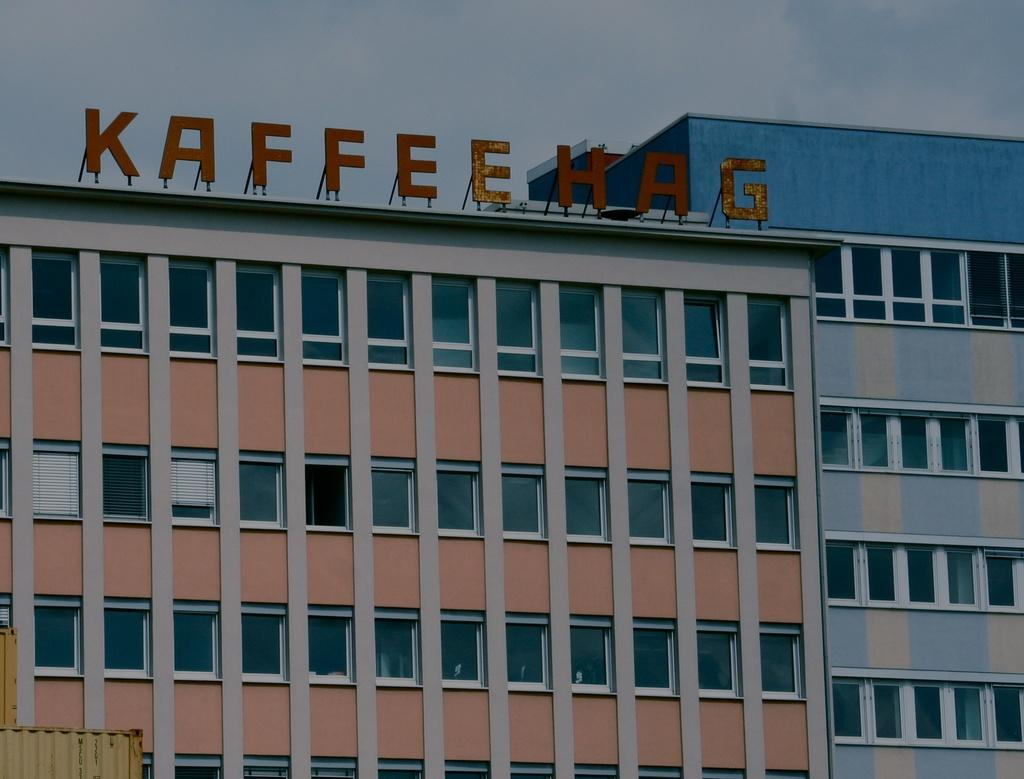What type of structure is in the image? There is a building in the image. What can be seen at the top of the image? Text is visible at the top of the image. What is present in the sky in the image? Clouds are present in the image. Can you hear the goose crying in the image? There is no goose or any sound present in the image, as it is a static visual representation. 